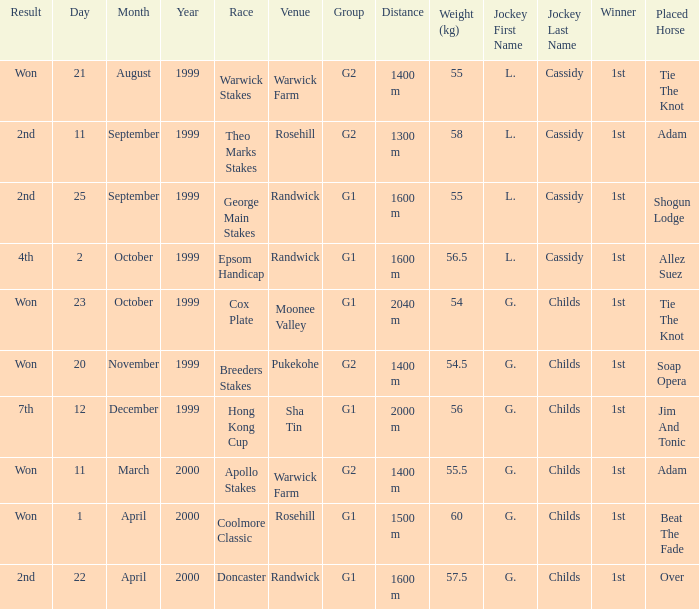List the weight for 56.5 kilograms. Epsom Handicap. 